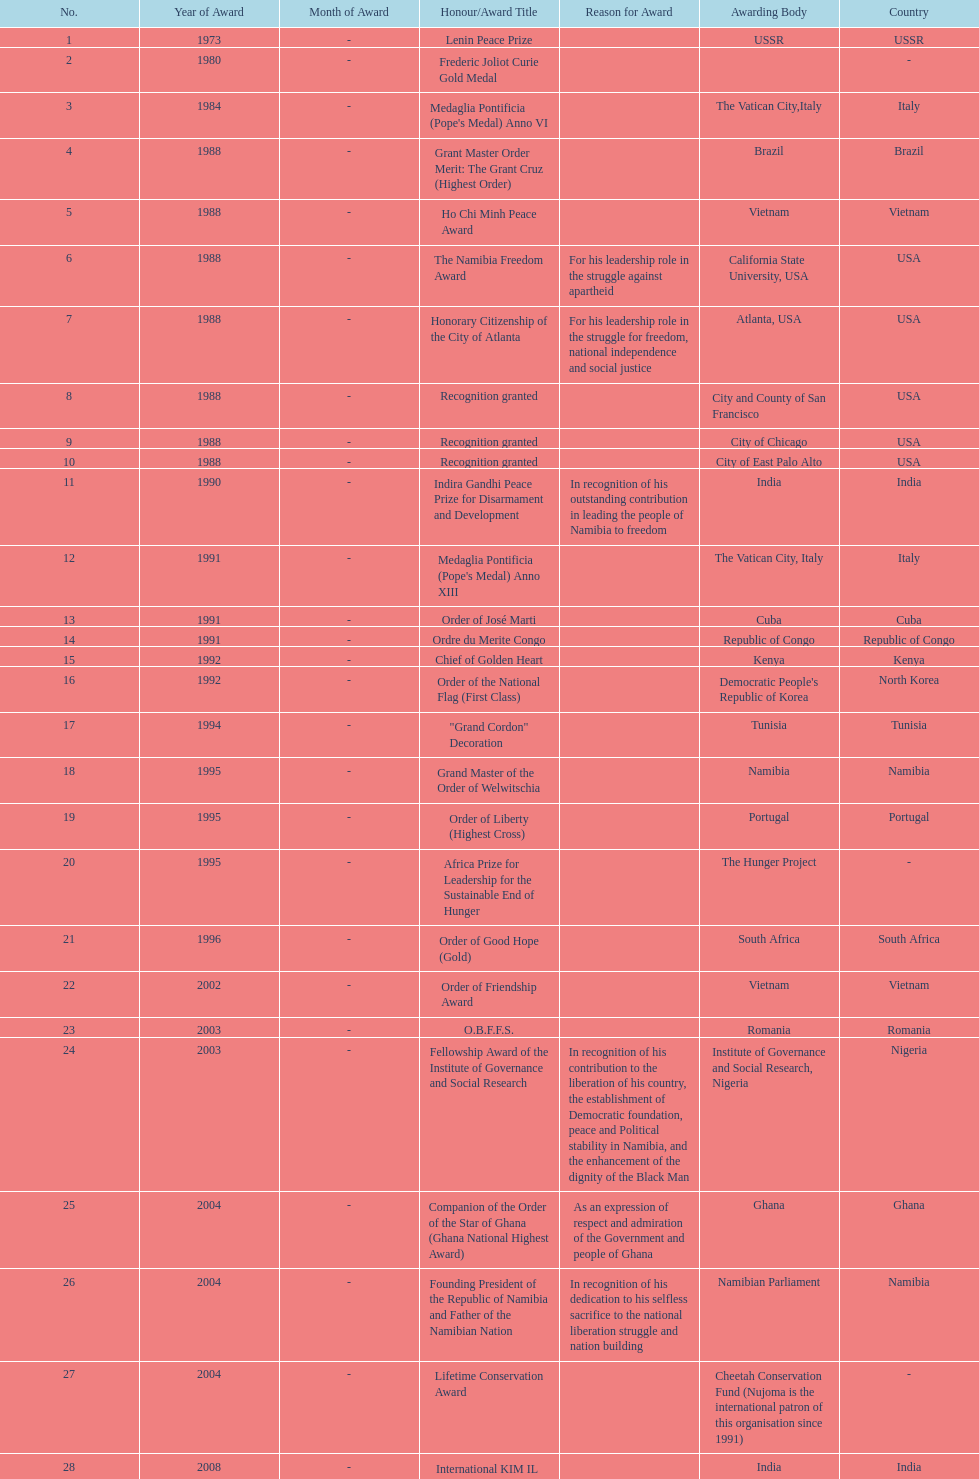What were the total number of honors/award titles listed according to this chart? 29. 